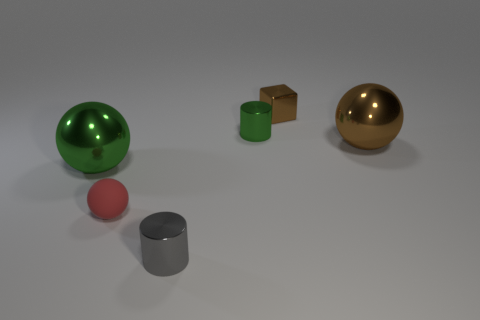Subtract all small red matte spheres. How many spheres are left? 2 Add 3 yellow objects. How many objects exist? 9 Add 6 big red matte spheres. How many big red matte spheres exist? 6 Subtract 0 red cylinders. How many objects are left? 6 Subtract all cylinders. How many objects are left? 4 Subtract all yellow cylinders. Subtract all brown blocks. How many cylinders are left? 2 Subtract all brown cubes. Subtract all green things. How many objects are left? 3 Add 1 green metallic objects. How many green metallic objects are left? 3 